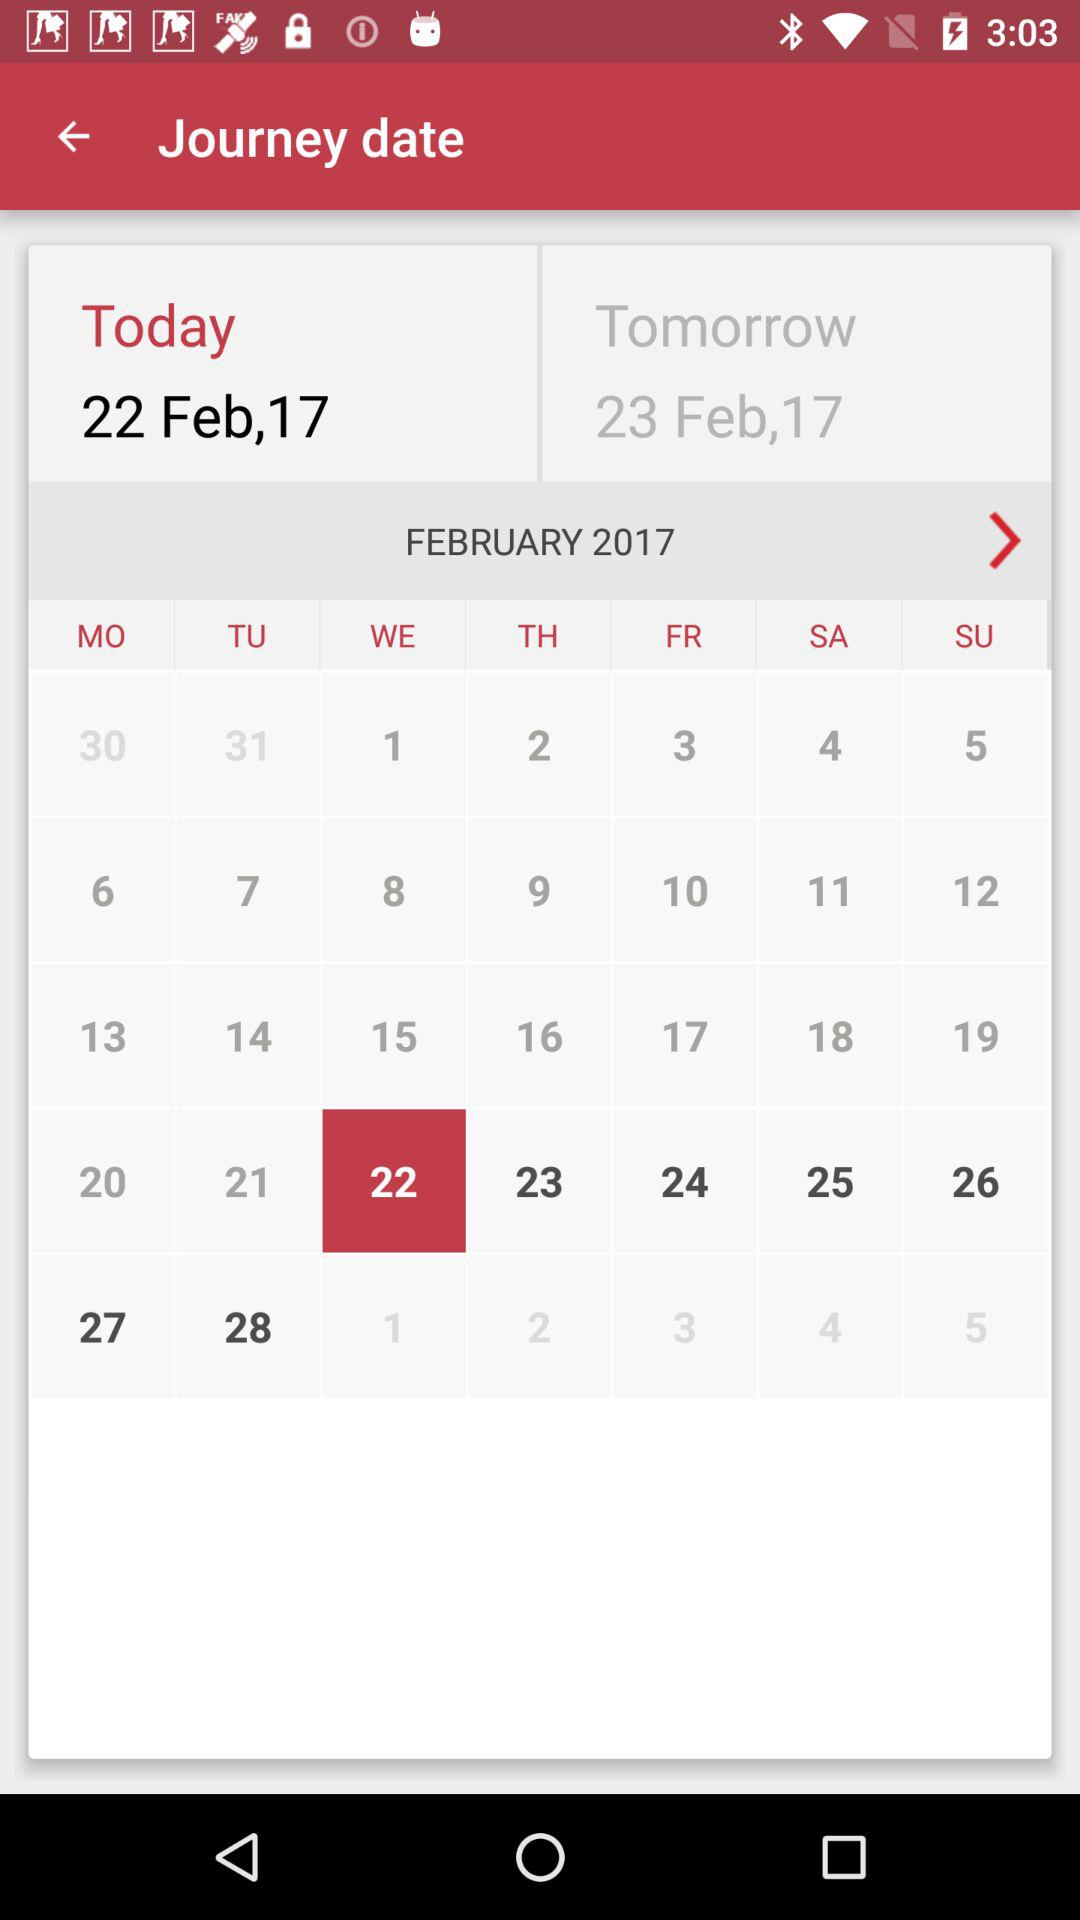What is today's date? Today's date is February 22, 2017. 